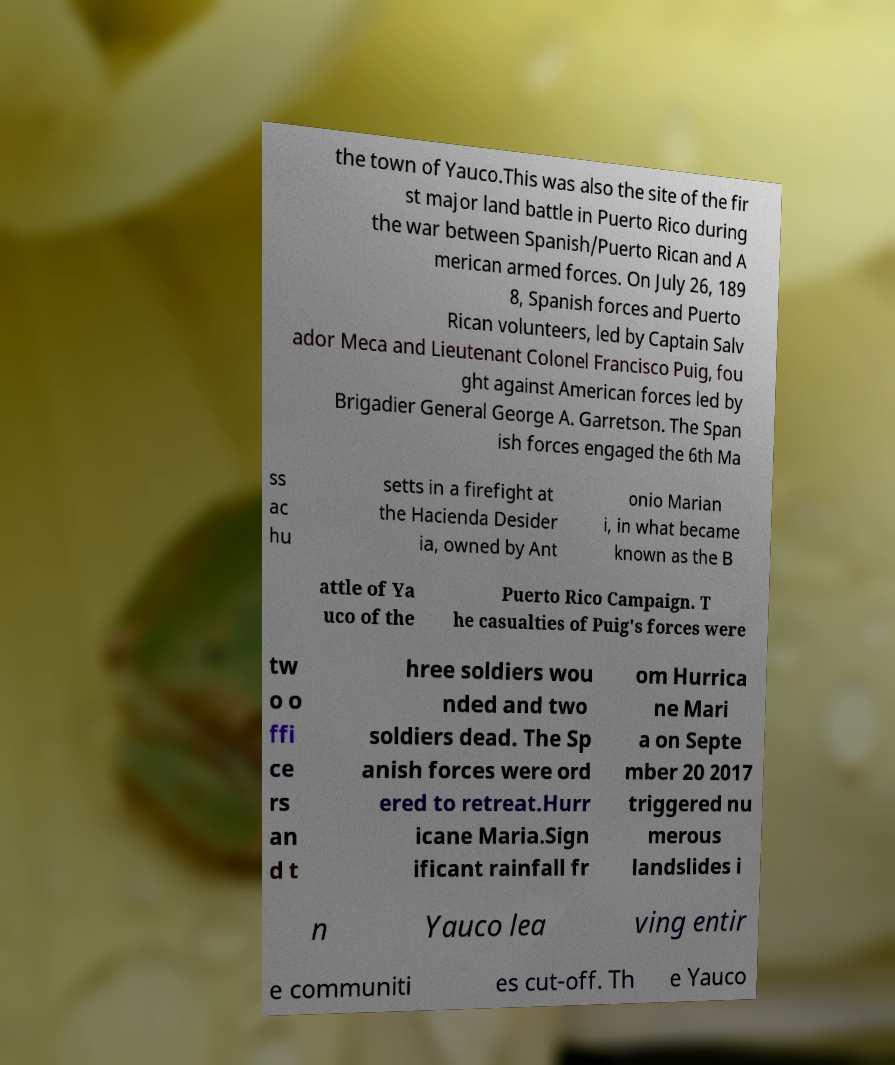Could you assist in decoding the text presented in this image and type it out clearly? the town of Yauco.This was also the site of the fir st major land battle in Puerto Rico during the war between Spanish/Puerto Rican and A merican armed forces. On July 26, 189 8, Spanish forces and Puerto Rican volunteers, led by Captain Salv ador Meca and Lieutenant Colonel Francisco Puig, fou ght against American forces led by Brigadier General George A. Garretson. The Span ish forces engaged the 6th Ma ss ac hu setts in a firefight at the Hacienda Desider ia, owned by Ant onio Marian i, in what became known as the B attle of Ya uco of the Puerto Rico Campaign. T he casualties of Puig's forces were tw o o ffi ce rs an d t hree soldiers wou nded and two soldiers dead. The Sp anish forces were ord ered to retreat.Hurr icane Maria.Sign ificant rainfall fr om Hurrica ne Mari a on Septe mber 20 2017 triggered nu merous landslides i n Yauco lea ving entir e communiti es cut-off. Th e Yauco 